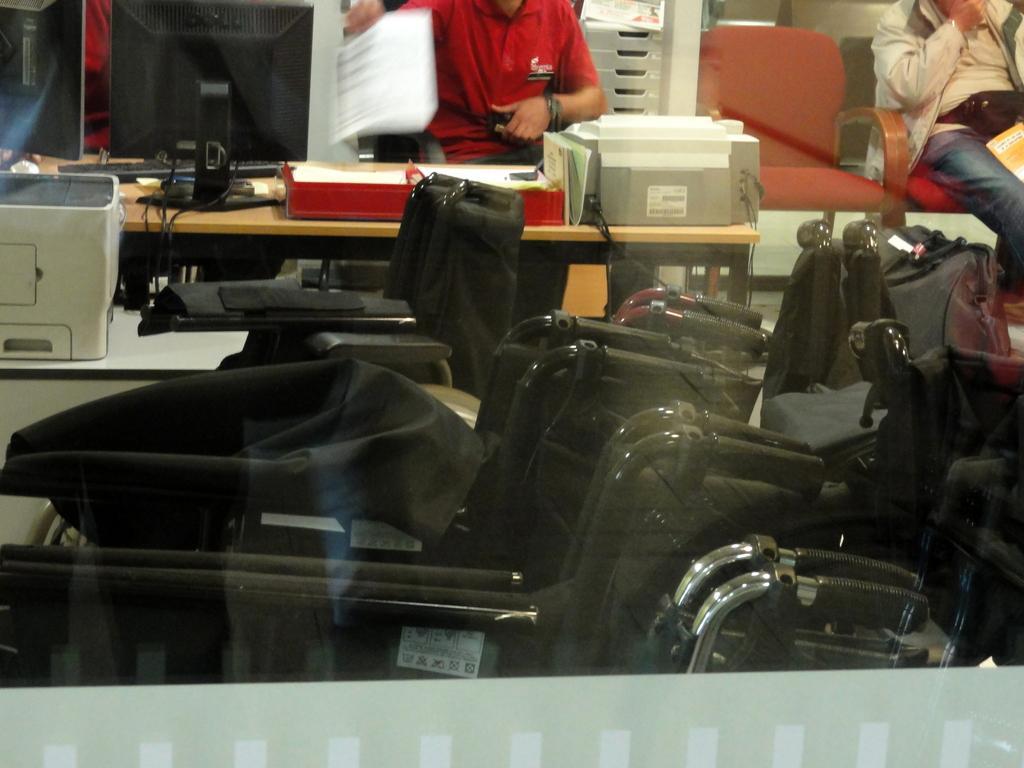Please provide a concise description of this image. In this image there are a few wheelchairs, beside the wheelchair there are a few fax machines and other objects on the table, on the other side of the table there are two people sitting in chairs. 